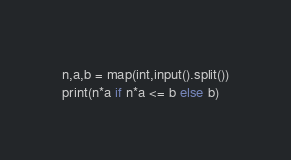<code> <loc_0><loc_0><loc_500><loc_500><_Python_>n,a,b = map(int,input().split())
print(n*a if n*a <= b else b)</code> 